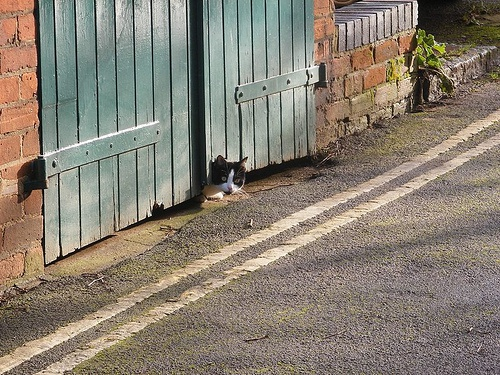Describe the objects in this image and their specific colors. I can see a cat in salmon, black, gray, darkgray, and lightgray tones in this image. 